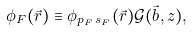Convert formula to latex. <formula><loc_0><loc_0><loc_500><loc_500>\phi _ { F } ( { \vec { r } } ) \equiv \phi _ { p _ { F } \, s _ { F } } ( \vec { r } ) \mathcal { G } ( \vec { b } , z ) ,</formula> 